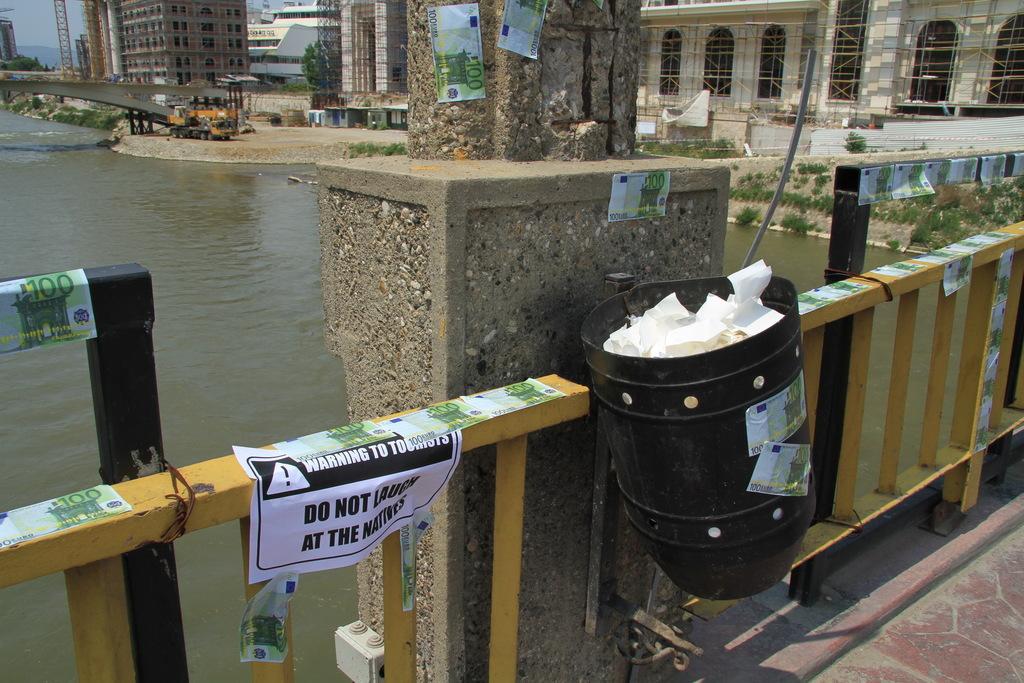What does the sign say not to do?
Provide a succinct answer. Laugh at the natives. What is the first word on the sign?
Your response must be concise. Warning. 